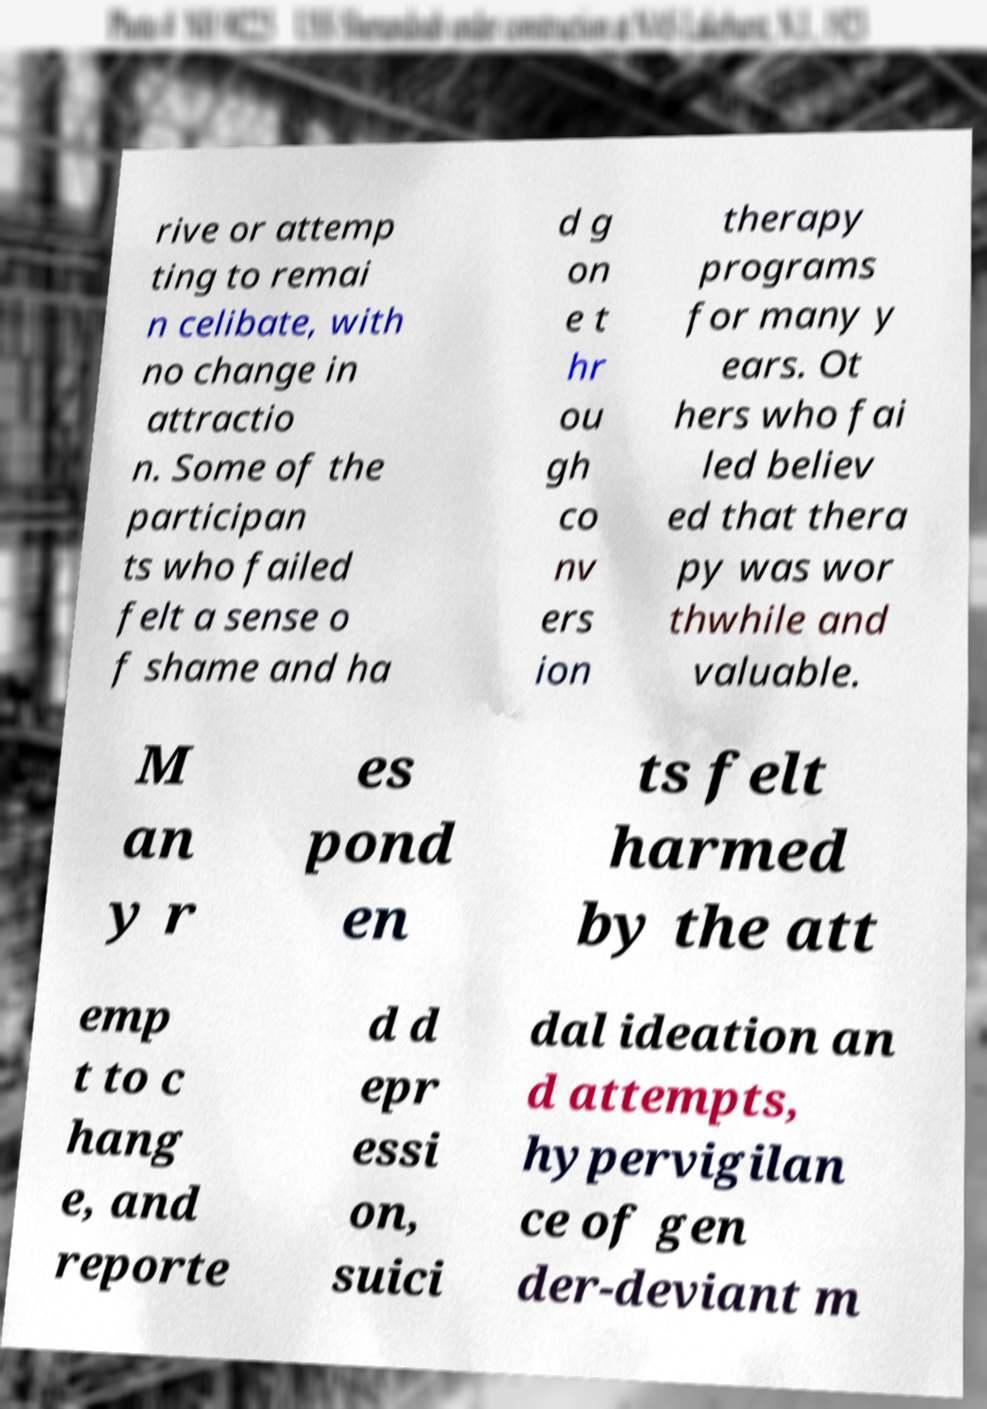What messages or text are displayed in this image? I need them in a readable, typed format. rive or attemp ting to remai n celibate, with no change in attractio n. Some of the participan ts who failed felt a sense o f shame and ha d g on e t hr ou gh co nv ers ion therapy programs for many y ears. Ot hers who fai led believ ed that thera py was wor thwhile and valuable. M an y r es pond en ts felt harmed by the att emp t to c hang e, and reporte d d epr essi on, suici dal ideation an d attempts, hypervigilan ce of gen der-deviant m 